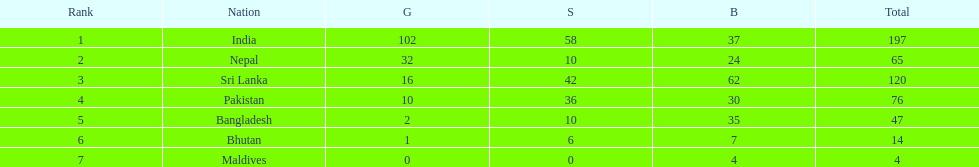How many countries have one more than 10 gold medals? 3. 